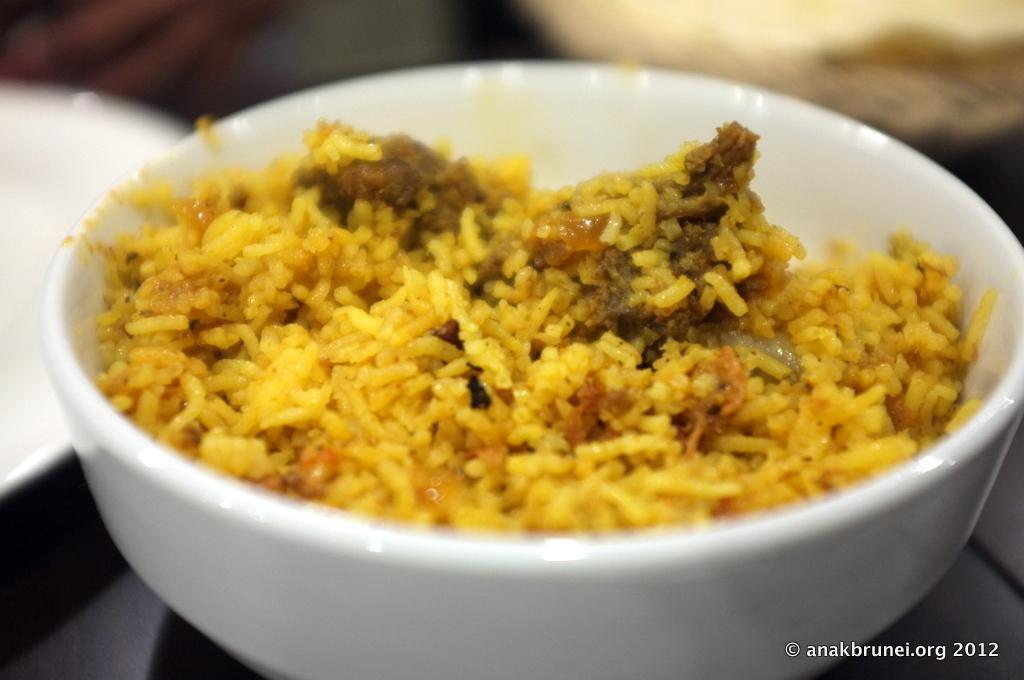What is in the bowl that is visible in the image? There is a bowl with rice and curry in the image. Where is the bowl located in the image? The bowl is on a platform. What is on the left side of the image? There is a plate on the left side of the image. Can you describe the background of the image? The background of the image is blurred. What can be seen in the background of the image? There is an object visible in the background. How does the care for the goldfish in the image? There is no goldfish present in the image, so it is not possible to discuss the care for a goldfish. 